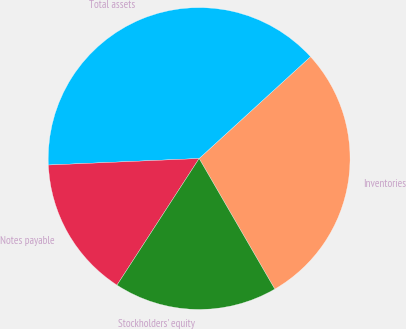Convert chart to OTSL. <chart><loc_0><loc_0><loc_500><loc_500><pie_chart><fcel>Inventories<fcel>Total assets<fcel>Notes payable<fcel>Stockholders' equity<nl><fcel>28.43%<fcel>38.9%<fcel>15.15%<fcel>17.52%<nl></chart> 